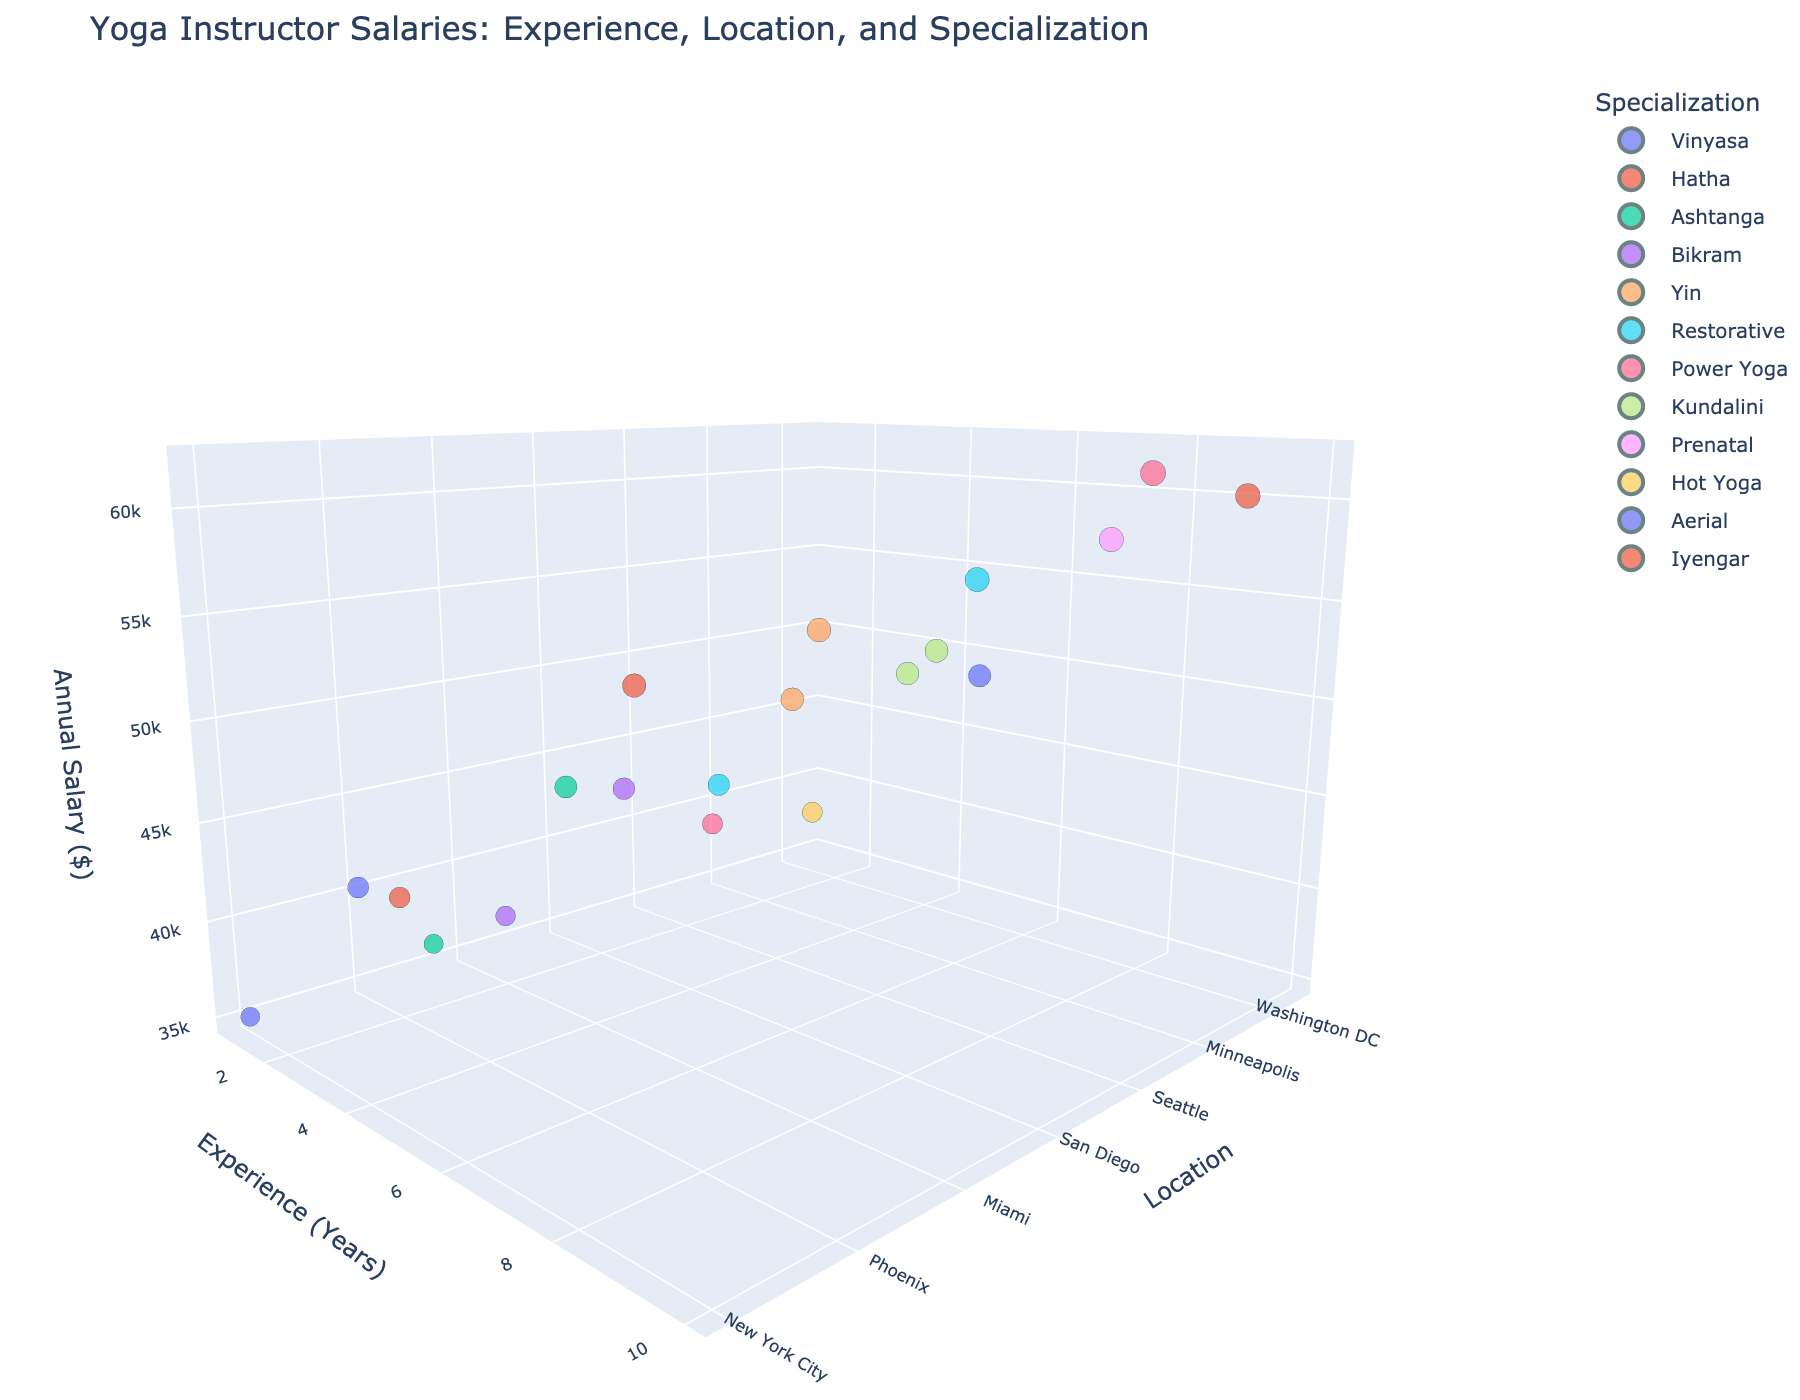What's the title of the figure? The title is usually displayed at the top of the figure. In this case, the figure has a title that summarizes the data being visualized, which is common in data plots and charts.
Answer: Yoga Instructor Salaries: Experience, Location, and Specialization How many years of experience does the highest-paid yoga instructor have? To determine the highest-paid yoga instructor, we look at the vertical axis (Salary) and find the highest point on the plot. The corresponding experience value on the horizontal axis indicates the years of experience of the highest-paid instructor.
Answer: 10 years What salary does a yoga instructor with 4 years of experience in Austin earn? Locate the point on the plot where the x-axis (Years of Experience) is 4 and the y-axis (Location) is Austin. The z-axis (Salary) value at this point represents the salary.
Answer: $45,000 Which specialization appears most frequently in the plot? The color attribute of the points represents different specializations. By examining the colors and the legend, we can count the frequency of each specialization.
Answer: Multiple specializations have similar frequencies (e.g., Vinyasa, Hatha, etc.) How do salaries compare between yoga instructors specializing in Power Yoga and Kundalini for the same amount of experience? Using the color and hover labels, identify points representing Power Yoga and Kundalini. Then, compare their z-values (Salary) for the same x-values (Years of Experience). Typically, you'll find Power Yoga and Kundalini represented by specific colors indicated in the legend. Compare their salaries.
Answer: Power Yoga generally pays more What is the average salary of a yoga instructor with 5 years of experience? Identify all the points on the plot with an x-value (Years of Experience) of 5. Then, average the z-values (Salaries) of those points. The points to consider are from Chicago, Washington DC, and Minneapolis. The salaries are $48,000, $49,000, and $50,000 respectively.
Answer: ($48,000 + $49,000 + $50,000) / 3 = $49,000 Which city offers the highest salary for yoga instructors with less than 3 years of experience? Locate points with x-values (Years of Experience) less than 3 and compare their z-values (Salary). The cities to consider would be New York City, Miami, Portland, Houston, Dallas, and New Orleans.
Answer: Houston offers the highest salary at $43,000 How does the salary trend with increasing years of experience? Examine the general direction of the z-values (Salary) as the x-values (Years of Experience) increase. If the plot shows rising points, there is an upward trend.
Answer: Salaries tend to increase with more years of experience What's the difference in salary between a yoga instructor with 8 years of experience in Denver and one with 8 years of experience in Nashville? Identify the points with 8 years of experience (x-axis) for Denver and Nashville, then calculate the difference between their z-values (Salaries).
Answer: $58,000 (Denver) - $57,000 (Nashville) = $1,000 